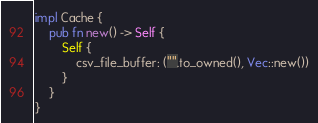Convert code to text. <code><loc_0><loc_0><loc_500><loc_500><_Rust_>
impl Cache {
	pub fn new() -> Self {
		Self {
			csv_file_buffer: ("".to_owned(), Vec::new())
		}
	}
}</code> 